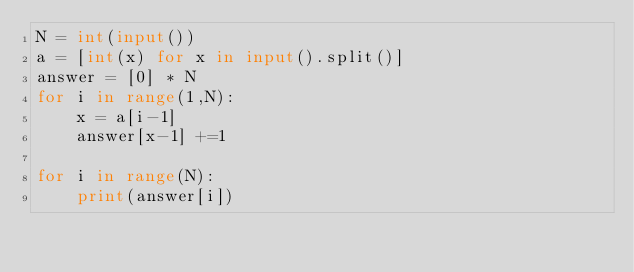Convert code to text. <code><loc_0><loc_0><loc_500><loc_500><_Python_>N = int(input())
a = [int(x) for x in input().split()]
answer = [0] * N
for i in range(1,N):
    x = a[i-1]
    answer[x-1] +=1

for i in range(N):
    print(answer[i])</code> 